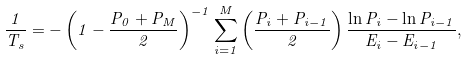Convert formula to latex. <formula><loc_0><loc_0><loc_500><loc_500>\frac { 1 } { T _ { s } } = - \left ( 1 - \frac { P _ { 0 } + P _ { M } } { 2 } \right ) ^ { - 1 } \sum _ { i = 1 } ^ { M } \left ( \frac { P _ { i } + P _ { i - 1 } } { 2 } \right ) \frac { \ln P _ { i } - \ln P _ { i - 1 } } { E _ { i } - E _ { i - 1 } } ,</formula> 